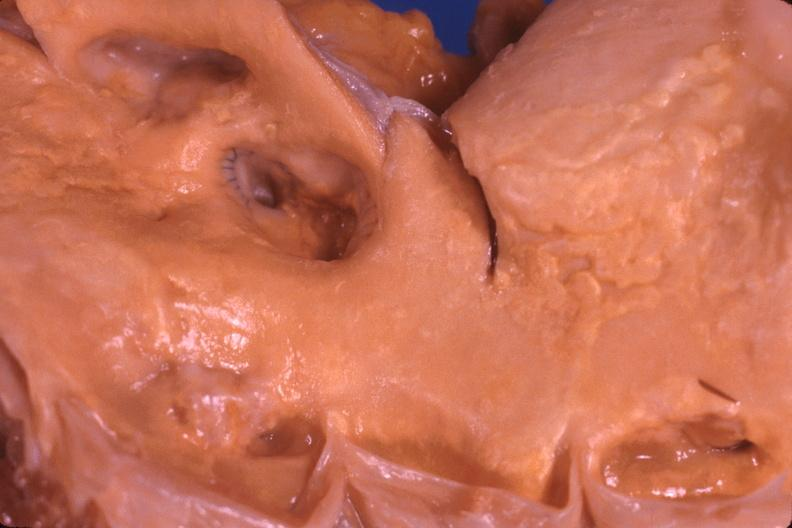does artery show saphenous vein graft anastamosis in aorta?
Answer the question using a single word or phrase. No 